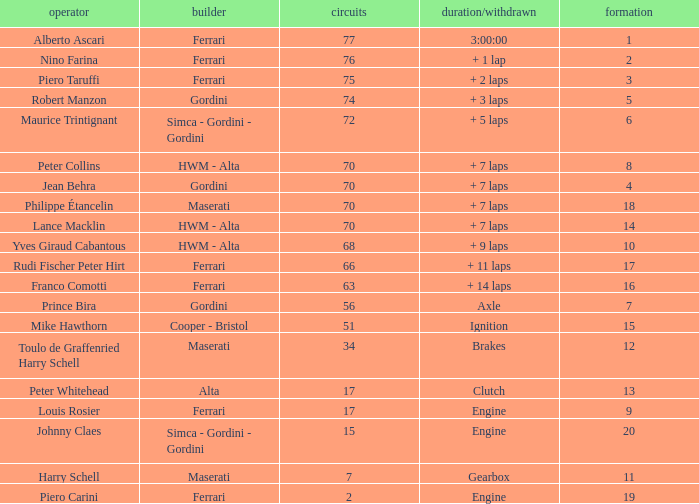Who drove the car with over 66 laps with a grid of 5? Robert Manzon. 